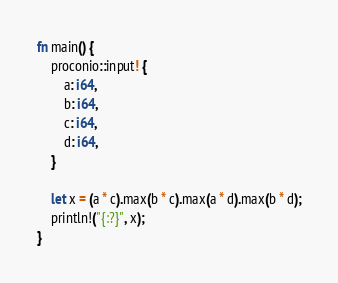Convert code to text. <code><loc_0><loc_0><loc_500><loc_500><_Rust_>fn main() {
    proconio::input! {
        a: i64,
        b: i64,
        c: i64,
        d: i64,
    }

    let x = (a * c).max(b * c).max(a * d).max(b * d);
    println!("{:?}", x);
}
</code> 